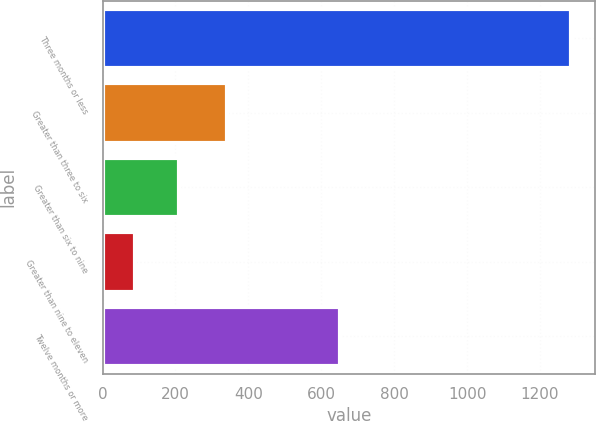Convert chart to OTSL. <chart><loc_0><loc_0><loc_500><loc_500><bar_chart><fcel>Three months or less<fcel>Greater than three to six<fcel>Greater than six to nine<fcel>Greater than nine to eleven<fcel>Twelve months or more<nl><fcel>1286<fcel>342<fcel>208.7<fcel>89<fcel>652<nl></chart> 